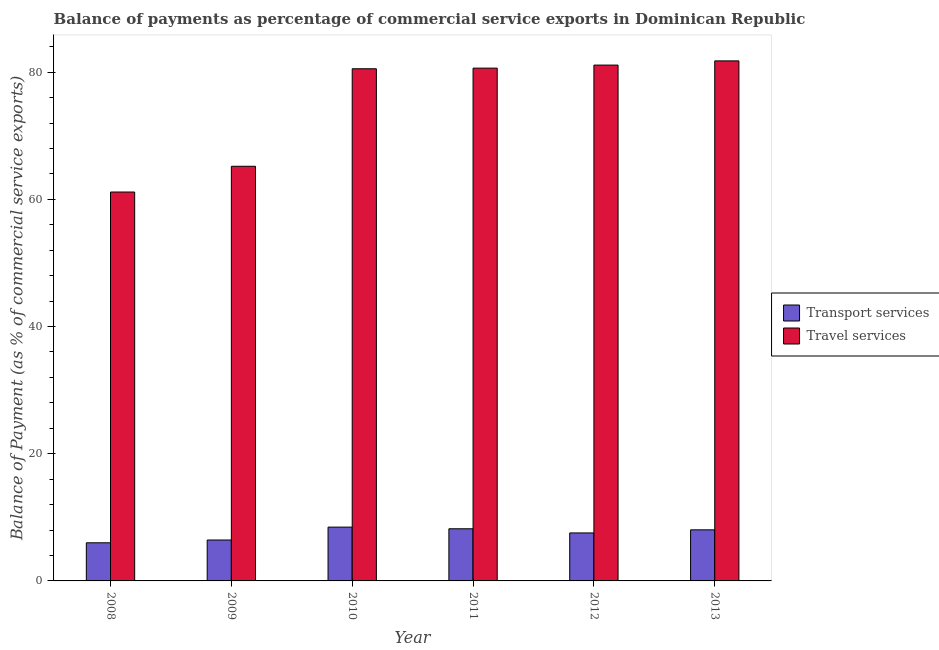How many bars are there on the 2nd tick from the right?
Keep it short and to the point. 2. In how many cases, is the number of bars for a given year not equal to the number of legend labels?
Ensure brevity in your answer.  0. What is the balance of payments of transport services in 2009?
Ensure brevity in your answer.  6.43. Across all years, what is the maximum balance of payments of transport services?
Keep it short and to the point. 8.46. Across all years, what is the minimum balance of payments of transport services?
Keep it short and to the point. 5.99. In which year was the balance of payments of transport services maximum?
Offer a very short reply. 2010. What is the total balance of payments of travel services in the graph?
Provide a short and direct response. 450.39. What is the difference between the balance of payments of travel services in 2009 and that in 2011?
Ensure brevity in your answer.  -15.43. What is the difference between the balance of payments of transport services in 2012 and the balance of payments of travel services in 2008?
Provide a succinct answer. 1.55. What is the average balance of payments of travel services per year?
Keep it short and to the point. 75.06. What is the ratio of the balance of payments of travel services in 2008 to that in 2012?
Give a very brief answer. 0.75. What is the difference between the highest and the second highest balance of payments of transport services?
Keep it short and to the point. 0.26. What is the difference between the highest and the lowest balance of payments of transport services?
Keep it short and to the point. 2.47. In how many years, is the balance of payments of travel services greater than the average balance of payments of travel services taken over all years?
Make the answer very short. 4. What does the 2nd bar from the left in 2010 represents?
Provide a succinct answer. Travel services. What does the 1st bar from the right in 2010 represents?
Offer a terse response. Travel services. Are all the bars in the graph horizontal?
Provide a succinct answer. No. How many years are there in the graph?
Offer a very short reply. 6. What is the difference between two consecutive major ticks on the Y-axis?
Your answer should be compact. 20. Does the graph contain grids?
Your answer should be compact. No. Where does the legend appear in the graph?
Provide a succinct answer. Center right. How are the legend labels stacked?
Offer a very short reply. Vertical. What is the title of the graph?
Provide a succinct answer. Balance of payments as percentage of commercial service exports in Dominican Republic. Does "Urban" appear as one of the legend labels in the graph?
Your response must be concise. No. What is the label or title of the X-axis?
Make the answer very short. Year. What is the label or title of the Y-axis?
Offer a terse response. Balance of Payment (as % of commercial service exports). What is the Balance of Payment (as % of commercial service exports) of Transport services in 2008?
Give a very brief answer. 5.99. What is the Balance of Payment (as % of commercial service exports) in Travel services in 2008?
Keep it short and to the point. 61.15. What is the Balance of Payment (as % of commercial service exports) of Transport services in 2009?
Your answer should be very brief. 6.43. What is the Balance of Payment (as % of commercial service exports) in Travel services in 2009?
Make the answer very short. 65.2. What is the Balance of Payment (as % of commercial service exports) in Transport services in 2010?
Keep it short and to the point. 8.46. What is the Balance of Payment (as % of commercial service exports) of Travel services in 2010?
Your answer should be compact. 80.53. What is the Balance of Payment (as % of commercial service exports) of Transport services in 2011?
Make the answer very short. 8.2. What is the Balance of Payment (as % of commercial service exports) in Travel services in 2011?
Your response must be concise. 80.63. What is the Balance of Payment (as % of commercial service exports) of Transport services in 2012?
Offer a very short reply. 7.55. What is the Balance of Payment (as % of commercial service exports) of Travel services in 2012?
Keep it short and to the point. 81.11. What is the Balance of Payment (as % of commercial service exports) in Transport services in 2013?
Make the answer very short. 8.03. What is the Balance of Payment (as % of commercial service exports) in Travel services in 2013?
Your answer should be compact. 81.77. Across all years, what is the maximum Balance of Payment (as % of commercial service exports) in Transport services?
Offer a very short reply. 8.46. Across all years, what is the maximum Balance of Payment (as % of commercial service exports) in Travel services?
Provide a short and direct response. 81.77. Across all years, what is the minimum Balance of Payment (as % of commercial service exports) in Transport services?
Your answer should be very brief. 5.99. Across all years, what is the minimum Balance of Payment (as % of commercial service exports) of Travel services?
Provide a succinct answer. 61.15. What is the total Balance of Payment (as % of commercial service exports) of Transport services in the graph?
Ensure brevity in your answer.  44.67. What is the total Balance of Payment (as % of commercial service exports) in Travel services in the graph?
Offer a very short reply. 450.39. What is the difference between the Balance of Payment (as % of commercial service exports) of Transport services in 2008 and that in 2009?
Provide a short and direct response. -0.44. What is the difference between the Balance of Payment (as % of commercial service exports) in Travel services in 2008 and that in 2009?
Make the answer very short. -4.05. What is the difference between the Balance of Payment (as % of commercial service exports) of Transport services in 2008 and that in 2010?
Offer a very short reply. -2.47. What is the difference between the Balance of Payment (as % of commercial service exports) in Travel services in 2008 and that in 2010?
Your answer should be very brief. -19.38. What is the difference between the Balance of Payment (as % of commercial service exports) in Transport services in 2008 and that in 2011?
Give a very brief answer. -2.21. What is the difference between the Balance of Payment (as % of commercial service exports) in Travel services in 2008 and that in 2011?
Make the answer very short. -19.48. What is the difference between the Balance of Payment (as % of commercial service exports) in Transport services in 2008 and that in 2012?
Your answer should be very brief. -1.55. What is the difference between the Balance of Payment (as % of commercial service exports) in Travel services in 2008 and that in 2012?
Keep it short and to the point. -19.96. What is the difference between the Balance of Payment (as % of commercial service exports) of Transport services in 2008 and that in 2013?
Provide a succinct answer. -2.04. What is the difference between the Balance of Payment (as % of commercial service exports) in Travel services in 2008 and that in 2013?
Offer a terse response. -20.62. What is the difference between the Balance of Payment (as % of commercial service exports) in Transport services in 2009 and that in 2010?
Offer a very short reply. -2.03. What is the difference between the Balance of Payment (as % of commercial service exports) of Travel services in 2009 and that in 2010?
Your response must be concise. -15.33. What is the difference between the Balance of Payment (as % of commercial service exports) in Transport services in 2009 and that in 2011?
Your answer should be very brief. -1.77. What is the difference between the Balance of Payment (as % of commercial service exports) in Travel services in 2009 and that in 2011?
Make the answer very short. -15.43. What is the difference between the Balance of Payment (as % of commercial service exports) of Transport services in 2009 and that in 2012?
Make the answer very short. -1.11. What is the difference between the Balance of Payment (as % of commercial service exports) of Travel services in 2009 and that in 2012?
Offer a very short reply. -15.91. What is the difference between the Balance of Payment (as % of commercial service exports) in Transport services in 2009 and that in 2013?
Your answer should be compact. -1.6. What is the difference between the Balance of Payment (as % of commercial service exports) in Travel services in 2009 and that in 2013?
Your answer should be very brief. -16.57. What is the difference between the Balance of Payment (as % of commercial service exports) in Transport services in 2010 and that in 2011?
Make the answer very short. 0.26. What is the difference between the Balance of Payment (as % of commercial service exports) of Travel services in 2010 and that in 2011?
Provide a succinct answer. -0.1. What is the difference between the Balance of Payment (as % of commercial service exports) of Transport services in 2010 and that in 2012?
Offer a terse response. 0.91. What is the difference between the Balance of Payment (as % of commercial service exports) of Travel services in 2010 and that in 2012?
Provide a short and direct response. -0.58. What is the difference between the Balance of Payment (as % of commercial service exports) of Transport services in 2010 and that in 2013?
Keep it short and to the point. 0.43. What is the difference between the Balance of Payment (as % of commercial service exports) of Travel services in 2010 and that in 2013?
Provide a short and direct response. -1.24. What is the difference between the Balance of Payment (as % of commercial service exports) of Transport services in 2011 and that in 2012?
Ensure brevity in your answer.  0.65. What is the difference between the Balance of Payment (as % of commercial service exports) in Travel services in 2011 and that in 2012?
Ensure brevity in your answer.  -0.48. What is the difference between the Balance of Payment (as % of commercial service exports) of Transport services in 2011 and that in 2013?
Make the answer very short. 0.17. What is the difference between the Balance of Payment (as % of commercial service exports) in Travel services in 2011 and that in 2013?
Offer a terse response. -1.14. What is the difference between the Balance of Payment (as % of commercial service exports) in Transport services in 2012 and that in 2013?
Offer a very short reply. -0.49. What is the difference between the Balance of Payment (as % of commercial service exports) in Travel services in 2012 and that in 2013?
Your answer should be compact. -0.66. What is the difference between the Balance of Payment (as % of commercial service exports) in Transport services in 2008 and the Balance of Payment (as % of commercial service exports) in Travel services in 2009?
Your answer should be very brief. -59.2. What is the difference between the Balance of Payment (as % of commercial service exports) of Transport services in 2008 and the Balance of Payment (as % of commercial service exports) of Travel services in 2010?
Provide a short and direct response. -74.54. What is the difference between the Balance of Payment (as % of commercial service exports) of Transport services in 2008 and the Balance of Payment (as % of commercial service exports) of Travel services in 2011?
Offer a terse response. -74.63. What is the difference between the Balance of Payment (as % of commercial service exports) of Transport services in 2008 and the Balance of Payment (as % of commercial service exports) of Travel services in 2012?
Keep it short and to the point. -75.11. What is the difference between the Balance of Payment (as % of commercial service exports) of Transport services in 2008 and the Balance of Payment (as % of commercial service exports) of Travel services in 2013?
Make the answer very short. -75.78. What is the difference between the Balance of Payment (as % of commercial service exports) in Transport services in 2009 and the Balance of Payment (as % of commercial service exports) in Travel services in 2010?
Offer a very short reply. -74.1. What is the difference between the Balance of Payment (as % of commercial service exports) in Transport services in 2009 and the Balance of Payment (as % of commercial service exports) in Travel services in 2011?
Your response must be concise. -74.2. What is the difference between the Balance of Payment (as % of commercial service exports) of Transport services in 2009 and the Balance of Payment (as % of commercial service exports) of Travel services in 2012?
Your answer should be compact. -74.68. What is the difference between the Balance of Payment (as % of commercial service exports) of Transport services in 2009 and the Balance of Payment (as % of commercial service exports) of Travel services in 2013?
Your answer should be very brief. -75.34. What is the difference between the Balance of Payment (as % of commercial service exports) of Transport services in 2010 and the Balance of Payment (as % of commercial service exports) of Travel services in 2011?
Provide a short and direct response. -72.17. What is the difference between the Balance of Payment (as % of commercial service exports) of Transport services in 2010 and the Balance of Payment (as % of commercial service exports) of Travel services in 2012?
Your response must be concise. -72.65. What is the difference between the Balance of Payment (as % of commercial service exports) in Transport services in 2010 and the Balance of Payment (as % of commercial service exports) in Travel services in 2013?
Make the answer very short. -73.31. What is the difference between the Balance of Payment (as % of commercial service exports) of Transport services in 2011 and the Balance of Payment (as % of commercial service exports) of Travel services in 2012?
Your answer should be very brief. -72.91. What is the difference between the Balance of Payment (as % of commercial service exports) of Transport services in 2011 and the Balance of Payment (as % of commercial service exports) of Travel services in 2013?
Make the answer very short. -73.57. What is the difference between the Balance of Payment (as % of commercial service exports) in Transport services in 2012 and the Balance of Payment (as % of commercial service exports) in Travel services in 2013?
Give a very brief answer. -74.22. What is the average Balance of Payment (as % of commercial service exports) of Transport services per year?
Give a very brief answer. 7.44. What is the average Balance of Payment (as % of commercial service exports) of Travel services per year?
Your response must be concise. 75.06. In the year 2008, what is the difference between the Balance of Payment (as % of commercial service exports) in Transport services and Balance of Payment (as % of commercial service exports) in Travel services?
Make the answer very short. -55.15. In the year 2009, what is the difference between the Balance of Payment (as % of commercial service exports) of Transport services and Balance of Payment (as % of commercial service exports) of Travel services?
Ensure brevity in your answer.  -58.77. In the year 2010, what is the difference between the Balance of Payment (as % of commercial service exports) in Transport services and Balance of Payment (as % of commercial service exports) in Travel services?
Keep it short and to the point. -72.07. In the year 2011, what is the difference between the Balance of Payment (as % of commercial service exports) in Transport services and Balance of Payment (as % of commercial service exports) in Travel services?
Offer a terse response. -72.43. In the year 2012, what is the difference between the Balance of Payment (as % of commercial service exports) in Transport services and Balance of Payment (as % of commercial service exports) in Travel services?
Offer a terse response. -73.56. In the year 2013, what is the difference between the Balance of Payment (as % of commercial service exports) in Transport services and Balance of Payment (as % of commercial service exports) in Travel services?
Ensure brevity in your answer.  -73.74. What is the ratio of the Balance of Payment (as % of commercial service exports) of Transport services in 2008 to that in 2009?
Your answer should be very brief. 0.93. What is the ratio of the Balance of Payment (as % of commercial service exports) in Travel services in 2008 to that in 2009?
Offer a very short reply. 0.94. What is the ratio of the Balance of Payment (as % of commercial service exports) in Transport services in 2008 to that in 2010?
Your answer should be very brief. 0.71. What is the ratio of the Balance of Payment (as % of commercial service exports) of Travel services in 2008 to that in 2010?
Provide a succinct answer. 0.76. What is the ratio of the Balance of Payment (as % of commercial service exports) of Transport services in 2008 to that in 2011?
Provide a succinct answer. 0.73. What is the ratio of the Balance of Payment (as % of commercial service exports) of Travel services in 2008 to that in 2011?
Your response must be concise. 0.76. What is the ratio of the Balance of Payment (as % of commercial service exports) in Transport services in 2008 to that in 2012?
Provide a succinct answer. 0.79. What is the ratio of the Balance of Payment (as % of commercial service exports) of Travel services in 2008 to that in 2012?
Your answer should be very brief. 0.75. What is the ratio of the Balance of Payment (as % of commercial service exports) of Transport services in 2008 to that in 2013?
Your response must be concise. 0.75. What is the ratio of the Balance of Payment (as % of commercial service exports) of Travel services in 2008 to that in 2013?
Provide a succinct answer. 0.75. What is the ratio of the Balance of Payment (as % of commercial service exports) of Transport services in 2009 to that in 2010?
Give a very brief answer. 0.76. What is the ratio of the Balance of Payment (as % of commercial service exports) of Travel services in 2009 to that in 2010?
Offer a terse response. 0.81. What is the ratio of the Balance of Payment (as % of commercial service exports) in Transport services in 2009 to that in 2011?
Offer a very short reply. 0.78. What is the ratio of the Balance of Payment (as % of commercial service exports) in Travel services in 2009 to that in 2011?
Ensure brevity in your answer.  0.81. What is the ratio of the Balance of Payment (as % of commercial service exports) of Transport services in 2009 to that in 2012?
Your answer should be compact. 0.85. What is the ratio of the Balance of Payment (as % of commercial service exports) in Travel services in 2009 to that in 2012?
Offer a very short reply. 0.8. What is the ratio of the Balance of Payment (as % of commercial service exports) in Transport services in 2009 to that in 2013?
Keep it short and to the point. 0.8. What is the ratio of the Balance of Payment (as % of commercial service exports) of Travel services in 2009 to that in 2013?
Provide a short and direct response. 0.8. What is the ratio of the Balance of Payment (as % of commercial service exports) in Transport services in 2010 to that in 2011?
Offer a terse response. 1.03. What is the ratio of the Balance of Payment (as % of commercial service exports) of Travel services in 2010 to that in 2011?
Make the answer very short. 1. What is the ratio of the Balance of Payment (as % of commercial service exports) of Transport services in 2010 to that in 2012?
Give a very brief answer. 1.12. What is the ratio of the Balance of Payment (as % of commercial service exports) of Travel services in 2010 to that in 2012?
Ensure brevity in your answer.  0.99. What is the ratio of the Balance of Payment (as % of commercial service exports) in Transport services in 2010 to that in 2013?
Provide a short and direct response. 1.05. What is the ratio of the Balance of Payment (as % of commercial service exports) in Travel services in 2010 to that in 2013?
Your answer should be very brief. 0.98. What is the ratio of the Balance of Payment (as % of commercial service exports) in Transport services in 2011 to that in 2012?
Provide a short and direct response. 1.09. What is the ratio of the Balance of Payment (as % of commercial service exports) in Transport services in 2011 to that in 2013?
Offer a very short reply. 1.02. What is the ratio of the Balance of Payment (as % of commercial service exports) in Travel services in 2011 to that in 2013?
Your answer should be very brief. 0.99. What is the ratio of the Balance of Payment (as % of commercial service exports) of Transport services in 2012 to that in 2013?
Provide a succinct answer. 0.94. What is the difference between the highest and the second highest Balance of Payment (as % of commercial service exports) in Transport services?
Make the answer very short. 0.26. What is the difference between the highest and the second highest Balance of Payment (as % of commercial service exports) of Travel services?
Keep it short and to the point. 0.66. What is the difference between the highest and the lowest Balance of Payment (as % of commercial service exports) of Transport services?
Provide a short and direct response. 2.47. What is the difference between the highest and the lowest Balance of Payment (as % of commercial service exports) in Travel services?
Your response must be concise. 20.62. 